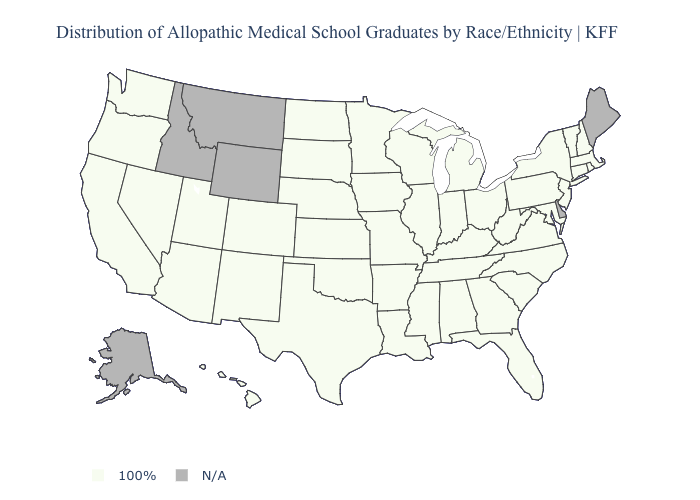What is the value of Idaho?
Be succinct. N/A. Which states have the lowest value in the USA?
Keep it brief. Alabama, Arizona, Arkansas, California, Colorado, Connecticut, Florida, Georgia, Hawaii, Illinois, Indiana, Iowa, Kansas, Kentucky, Louisiana, Maryland, Massachusetts, Michigan, Minnesota, Mississippi, Missouri, Nebraska, Nevada, New Hampshire, New Jersey, New Mexico, New York, North Carolina, North Dakota, Ohio, Oklahoma, Oregon, Pennsylvania, Rhode Island, South Carolina, South Dakota, Tennessee, Texas, Utah, Vermont, Virginia, Washington, West Virginia, Wisconsin. What is the value of Rhode Island?
Concise answer only. 100%. What is the lowest value in the Northeast?
Answer briefly. 100%. Which states hav the highest value in the Northeast?
Answer briefly. Connecticut, Massachusetts, New Hampshire, New Jersey, New York, Pennsylvania, Rhode Island, Vermont. Name the states that have a value in the range 100%?
Concise answer only. Alabama, Arizona, Arkansas, California, Colorado, Connecticut, Florida, Georgia, Hawaii, Illinois, Indiana, Iowa, Kansas, Kentucky, Louisiana, Maryland, Massachusetts, Michigan, Minnesota, Mississippi, Missouri, Nebraska, Nevada, New Hampshire, New Jersey, New Mexico, New York, North Carolina, North Dakota, Ohio, Oklahoma, Oregon, Pennsylvania, Rhode Island, South Carolina, South Dakota, Tennessee, Texas, Utah, Vermont, Virginia, Washington, West Virginia, Wisconsin. Name the states that have a value in the range N/A?
Write a very short answer. Alaska, Delaware, Idaho, Maine, Montana, Wyoming. Name the states that have a value in the range N/A?
Quick response, please. Alaska, Delaware, Idaho, Maine, Montana, Wyoming. Name the states that have a value in the range 100%?
Quick response, please. Alabama, Arizona, Arkansas, California, Colorado, Connecticut, Florida, Georgia, Hawaii, Illinois, Indiana, Iowa, Kansas, Kentucky, Louisiana, Maryland, Massachusetts, Michigan, Minnesota, Mississippi, Missouri, Nebraska, Nevada, New Hampshire, New Jersey, New Mexico, New York, North Carolina, North Dakota, Ohio, Oklahoma, Oregon, Pennsylvania, Rhode Island, South Carolina, South Dakota, Tennessee, Texas, Utah, Vermont, Virginia, Washington, West Virginia, Wisconsin. What is the highest value in the USA?
Quick response, please. 100%. Does the map have missing data?
Give a very brief answer. Yes. What is the highest value in states that border North Dakota?
Give a very brief answer. 100%. 